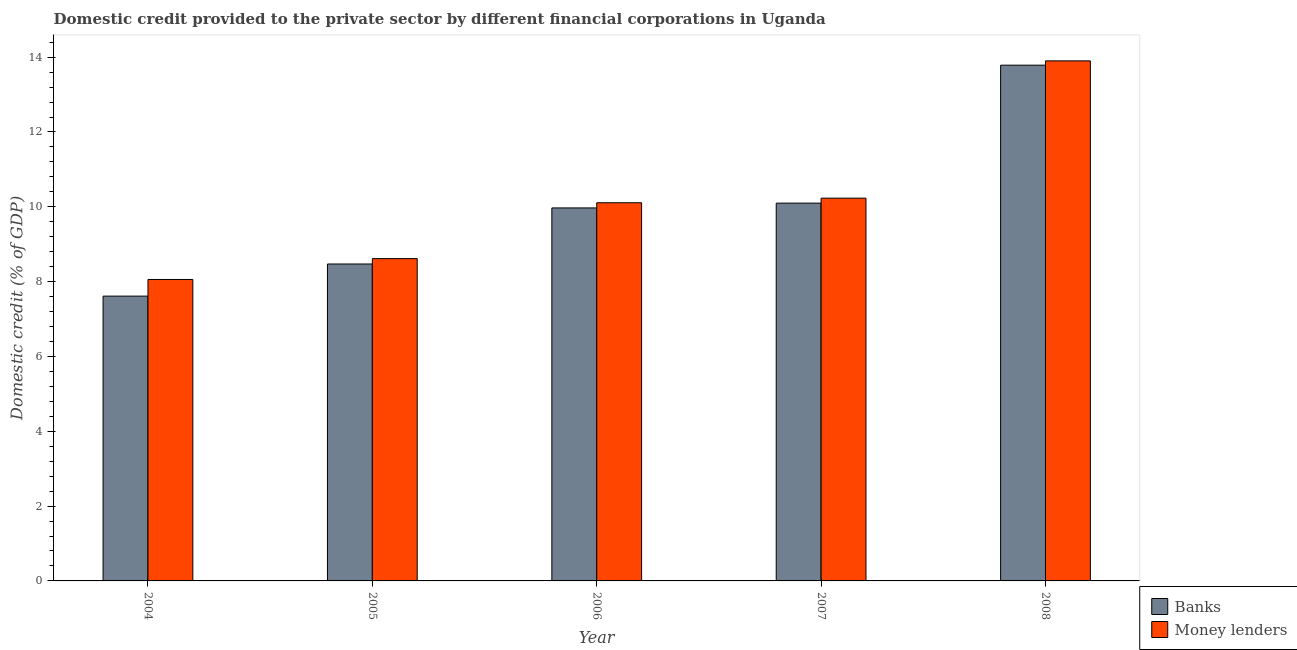How many groups of bars are there?
Your response must be concise. 5. How many bars are there on the 4th tick from the left?
Provide a short and direct response. 2. How many bars are there on the 5th tick from the right?
Provide a short and direct response. 2. In how many cases, is the number of bars for a given year not equal to the number of legend labels?
Provide a short and direct response. 0. What is the domestic credit provided by money lenders in 2007?
Your answer should be very brief. 10.23. Across all years, what is the maximum domestic credit provided by banks?
Provide a succinct answer. 13.79. Across all years, what is the minimum domestic credit provided by money lenders?
Your answer should be very brief. 8.06. What is the total domestic credit provided by banks in the graph?
Your answer should be very brief. 49.94. What is the difference between the domestic credit provided by banks in 2007 and that in 2008?
Keep it short and to the point. -3.69. What is the difference between the domestic credit provided by banks in 2007 and the domestic credit provided by money lenders in 2004?
Your answer should be compact. 2.49. What is the average domestic credit provided by banks per year?
Your answer should be compact. 9.99. In how many years, is the domestic credit provided by banks greater than 2 %?
Your answer should be compact. 5. What is the ratio of the domestic credit provided by money lenders in 2007 to that in 2008?
Your answer should be very brief. 0.74. Is the domestic credit provided by banks in 2004 less than that in 2008?
Your answer should be compact. Yes. What is the difference between the highest and the second highest domestic credit provided by banks?
Make the answer very short. 3.69. What is the difference between the highest and the lowest domestic credit provided by money lenders?
Provide a short and direct response. 5.84. In how many years, is the domestic credit provided by banks greater than the average domestic credit provided by banks taken over all years?
Offer a terse response. 2. Is the sum of the domestic credit provided by banks in 2004 and 2005 greater than the maximum domestic credit provided by money lenders across all years?
Provide a succinct answer. Yes. What does the 2nd bar from the left in 2005 represents?
Keep it short and to the point. Money lenders. What does the 2nd bar from the right in 2006 represents?
Keep it short and to the point. Banks. How many bars are there?
Offer a very short reply. 10. Are all the bars in the graph horizontal?
Your answer should be compact. No. How many years are there in the graph?
Your answer should be very brief. 5. Are the values on the major ticks of Y-axis written in scientific E-notation?
Provide a succinct answer. No. Does the graph contain grids?
Offer a very short reply. No. How are the legend labels stacked?
Keep it short and to the point. Vertical. What is the title of the graph?
Your response must be concise. Domestic credit provided to the private sector by different financial corporations in Uganda. What is the label or title of the X-axis?
Your answer should be compact. Year. What is the label or title of the Y-axis?
Make the answer very short. Domestic credit (% of GDP). What is the Domestic credit (% of GDP) in Banks in 2004?
Offer a very short reply. 7.61. What is the Domestic credit (% of GDP) of Money lenders in 2004?
Your answer should be very brief. 8.06. What is the Domestic credit (% of GDP) in Banks in 2005?
Give a very brief answer. 8.47. What is the Domestic credit (% of GDP) of Money lenders in 2005?
Give a very brief answer. 8.62. What is the Domestic credit (% of GDP) in Banks in 2006?
Ensure brevity in your answer.  9.97. What is the Domestic credit (% of GDP) of Money lenders in 2006?
Give a very brief answer. 10.11. What is the Domestic credit (% of GDP) of Banks in 2007?
Offer a terse response. 10.1. What is the Domestic credit (% of GDP) of Money lenders in 2007?
Ensure brevity in your answer.  10.23. What is the Domestic credit (% of GDP) of Banks in 2008?
Give a very brief answer. 13.79. What is the Domestic credit (% of GDP) of Money lenders in 2008?
Your response must be concise. 13.9. Across all years, what is the maximum Domestic credit (% of GDP) of Banks?
Ensure brevity in your answer.  13.79. Across all years, what is the maximum Domestic credit (% of GDP) of Money lenders?
Ensure brevity in your answer.  13.9. Across all years, what is the minimum Domestic credit (% of GDP) of Banks?
Give a very brief answer. 7.61. Across all years, what is the minimum Domestic credit (% of GDP) in Money lenders?
Give a very brief answer. 8.06. What is the total Domestic credit (% of GDP) in Banks in the graph?
Your response must be concise. 49.94. What is the total Domestic credit (% of GDP) of Money lenders in the graph?
Your answer should be compact. 50.91. What is the difference between the Domestic credit (% of GDP) of Banks in 2004 and that in 2005?
Offer a very short reply. -0.86. What is the difference between the Domestic credit (% of GDP) in Money lenders in 2004 and that in 2005?
Keep it short and to the point. -0.56. What is the difference between the Domestic credit (% of GDP) of Banks in 2004 and that in 2006?
Keep it short and to the point. -2.36. What is the difference between the Domestic credit (% of GDP) in Money lenders in 2004 and that in 2006?
Provide a succinct answer. -2.05. What is the difference between the Domestic credit (% of GDP) of Banks in 2004 and that in 2007?
Keep it short and to the point. -2.49. What is the difference between the Domestic credit (% of GDP) of Money lenders in 2004 and that in 2007?
Ensure brevity in your answer.  -2.17. What is the difference between the Domestic credit (% of GDP) of Banks in 2004 and that in 2008?
Give a very brief answer. -6.17. What is the difference between the Domestic credit (% of GDP) of Money lenders in 2004 and that in 2008?
Keep it short and to the point. -5.84. What is the difference between the Domestic credit (% of GDP) of Banks in 2005 and that in 2006?
Keep it short and to the point. -1.5. What is the difference between the Domestic credit (% of GDP) of Money lenders in 2005 and that in 2006?
Your answer should be very brief. -1.49. What is the difference between the Domestic credit (% of GDP) of Banks in 2005 and that in 2007?
Provide a succinct answer. -1.63. What is the difference between the Domestic credit (% of GDP) in Money lenders in 2005 and that in 2007?
Give a very brief answer. -1.62. What is the difference between the Domestic credit (% of GDP) of Banks in 2005 and that in 2008?
Give a very brief answer. -5.31. What is the difference between the Domestic credit (% of GDP) of Money lenders in 2005 and that in 2008?
Provide a short and direct response. -5.29. What is the difference between the Domestic credit (% of GDP) of Banks in 2006 and that in 2007?
Provide a short and direct response. -0.13. What is the difference between the Domestic credit (% of GDP) in Money lenders in 2006 and that in 2007?
Make the answer very short. -0.12. What is the difference between the Domestic credit (% of GDP) in Banks in 2006 and that in 2008?
Your answer should be compact. -3.82. What is the difference between the Domestic credit (% of GDP) of Money lenders in 2006 and that in 2008?
Give a very brief answer. -3.79. What is the difference between the Domestic credit (% of GDP) of Banks in 2007 and that in 2008?
Your answer should be very brief. -3.69. What is the difference between the Domestic credit (% of GDP) of Money lenders in 2007 and that in 2008?
Your answer should be very brief. -3.67. What is the difference between the Domestic credit (% of GDP) of Banks in 2004 and the Domestic credit (% of GDP) of Money lenders in 2005?
Provide a short and direct response. -1. What is the difference between the Domestic credit (% of GDP) in Banks in 2004 and the Domestic credit (% of GDP) in Money lenders in 2006?
Your answer should be compact. -2.5. What is the difference between the Domestic credit (% of GDP) of Banks in 2004 and the Domestic credit (% of GDP) of Money lenders in 2007?
Your answer should be compact. -2.62. What is the difference between the Domestic credit (% of GDP) in Banks in 2004 and the Domestic credit (% of GDP) in Money lenders in 2008?
Offer a terse response. -6.29. What is the difference between the Domestic credit (% of GDP) of Banks in 2005 and the Domestic credit (% of GDP) of Money lenders in 2006?
Offer a very short reply. -1.64. What is the difference between the Domestic credit (% of GDP) of Banks in 2005 and the Domestic credit (% of GDP) of Money lenders in 2007?
Your answer should be compact. -1.76. What is the difference between the Domestic credit (% of GDP) of Banks in 2005 and the Domestic credit (% of GDP) of Money lenders in 2008?
Give a very brief answer. -5.43. What is the difference between the Domestic credit (% of GDP) of Banks in 2006 and the Domestic credit (% of GDP) of Money lenders in 2007?
Offer a terse response. -0.26. What is the difference between the Domestic credit (% of GDP) in Banks in 2006 and the Domestic credit (% of GDP) in Money lenders in 2008?
Give a very brief answer. -3.93. What is the difference between the Domestic credit (% of GDP) of Banks in 2007 and the Domestic credit (% of GDP) of Money lenders in 2008?
Keep it short and to the point. -3.8. What is the average Domestic credit (% of GDP) in Banks per year?
Your response must be concise. 9.99. What is the average Domestic credit (% of GDP) of Money lenders per year?
Keep it short and to the point. 10.18. In the year 2004, what is the difference between the Domestic credit (% of GDP) of Banks and Domestic credit (% of GDP) of Money lenders?
Your answer should be very brief. -0.44. In the year 2005, what is the difference between the Domestic credit (% of GDP) in Banks and Domestic credit (% of GDP) in Money lenders?
Your answer should be compact. -0.14. In the year 2006, what is the difference between the Domestic credit (% of GDP) in Banks and Domestic credit (% of GDP) in Money lenders?
Give a very brief answer. -0.14. In the year 2007, what is the difference between the Domestic credit (% of GDP) in Banks and Domestic credit (% of GDP) in Money lenders?
Offer a terse response. -0.13. In the year 2008, what is the difference between the Domestic credit (% of GDP) in Banks and Domestic credit (% of GDP) in Money lenders?
Ensure brevity in your answer.  -0.12. What is the ratio of the Domestic credit (% of GDP) of Banks in 2004 to that in 2005?
Offer a very short reply. 0.9. What is the ratio of the Domestic credit (% of GDP) in Money lenders in 2004 to that in 2005?
Your answer should be very brief. 0.94. What is the ratio of the Domestic credit (% of GDP) of Banks in 2004 to that in 2006?
Keep it short and to the point. 0.76. What is the ratio of the Domestic credit (% of GDP) in Money lenders in 2004 to that in 2006?
Your answer should be compact. 0.8. What is the ratio of the Domestic credit (% of GDP) of Banks in 2004 to that in 2007?
Your answer should be compact. 0.75. What is the ratio of the Domestic credit (% of GDP) of Money lenders in 2004 to that in 2007?
Make the answer very short. 0.79. What is the ratio of the Domestic credit (% of GDP) of Banks in 2004 to that in 2008?
Offer a very short reply. 0.55. What is the ratio of the Domestic credit (% of GDP) in Money lenders in 2004 to that in 2008?
Keep it short and to the point. 0.58. What is the ratio of the Domestic credit (% of GDP) of Banks in 2005 to that in 2006?
Provide a short and direct response. 0.85. What is the ratio of the Domestic credit (% of GDP) of Money lenders in 2005 to that in 2006?
Your answer should be compact. 0.85. What is the ratio of the Domestic credit (% of GDP) of Banks in 2005 to that in 2007?
Keep it short and to the point. 0.84. What is the ratio of the Domestic credit (% of GDP) of Money lenders in 2005 to that in 2007?
Provide a succinct answer. 0.84. What is the ratio of the Domestic credit (% of GDP) of Banks in 2005 to that in 2008?
Provide a short and direct response. 0.61. What is the ratio of the Domestic credit (% of GDP) in Money lenders in 2005 to that in 2008?
Offer a very short reply. 0.62. What is the ratio of the Domestic credit (% of GDP) in Banks in 2006 to that in 2007?
Your answer should be very brief. 0.99. What is the ratio of the Domestic credit (% of GDP) of Money lenders in 2006 to that in 2007?
Ensure brevity in your answer.  0.99. What is the ratio of the Domestic credit (% of GDP) of Banks in 2006 to that in 2008?
Your response must be concise. 0.72. What is the ratio of the Domestic credit (% of GDP) in Money lenders in 2006 to that in 2008?
Your response must be concise. 0.73. What is the ratio of the Domestic credit (% of GDP) in Banks in 2007 to that in 2008?
Provide a short and direct response. 0.73. What is the ratio of the Domestic credit (% of GDP) in Money lenders in 2007 to that in 2008?
Offer a very short reply. 0.74. What is the difference between the highest and the second highest Domestic credit (% of GDP) in Banks?
Make the answer very short. 3.69. What is the difference between the highest and the second highest Domestic credit (% of GDP) of Money lenders?
Offer a very short reply. 3.67. What is the difference between the highest and the lowest Domestic credit (% of GDP) in Banks?
Make the answer very short. 6.17. What is the difference between the highest and the lowest Domestic credit (% of GDP) of Money lenders?
Offer a very short reply. 5.84. 